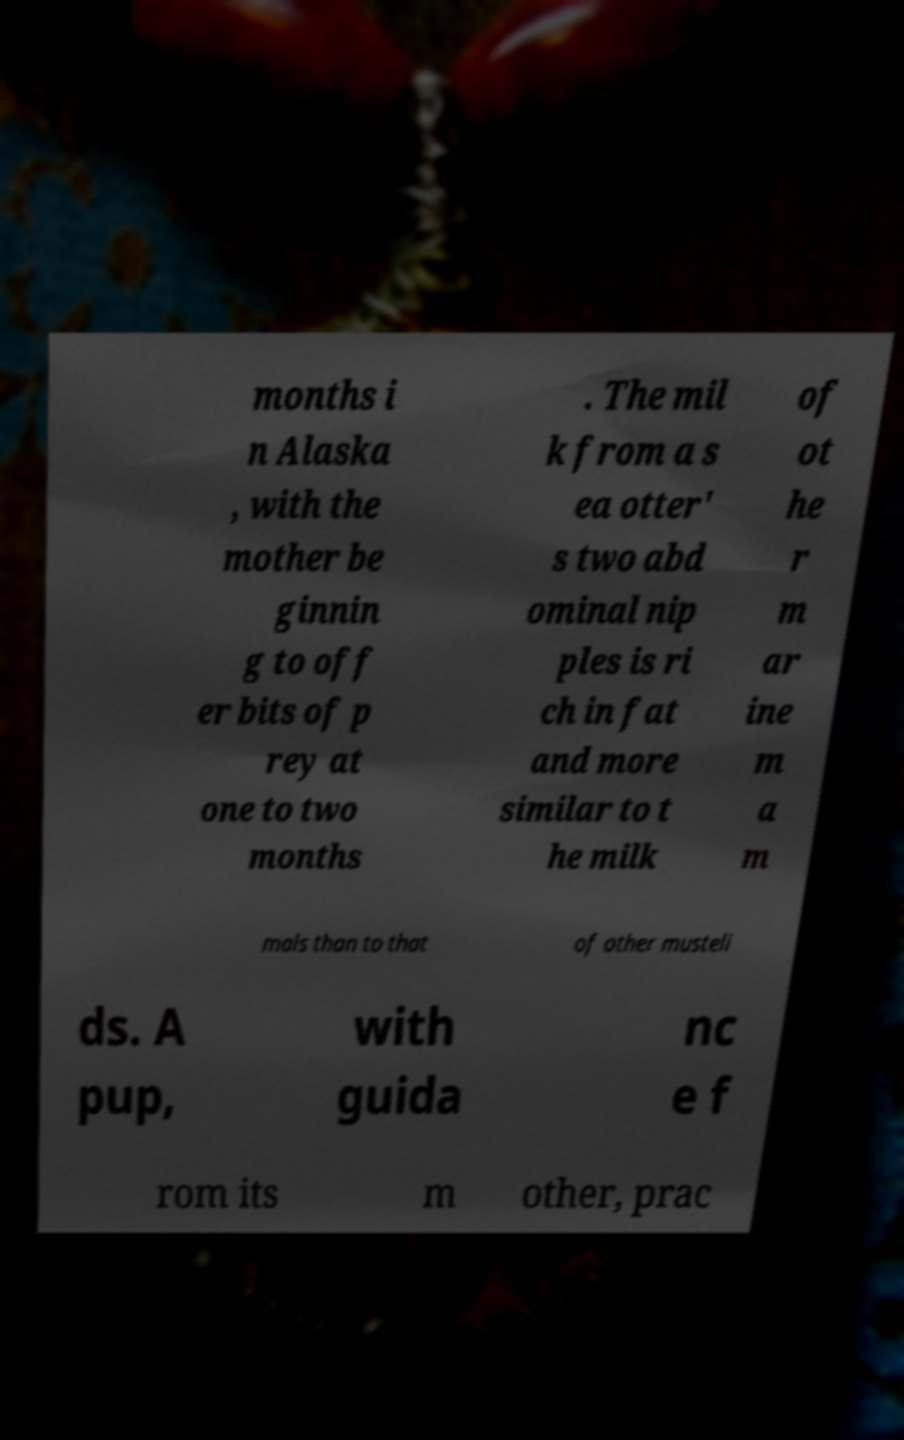Could you extract and type out the text from this image? months i n Alaska , with the mother be ginnin g to off er bits of p rey at one to two months . The mil k from a s ea otter' s two abd ominal nip ples is ri ch in fat and more similar to t he milk of ot he r m ar ine m a m mals than to that of other musteli ds. A pup, with guida nc e f rom its m other, prac 